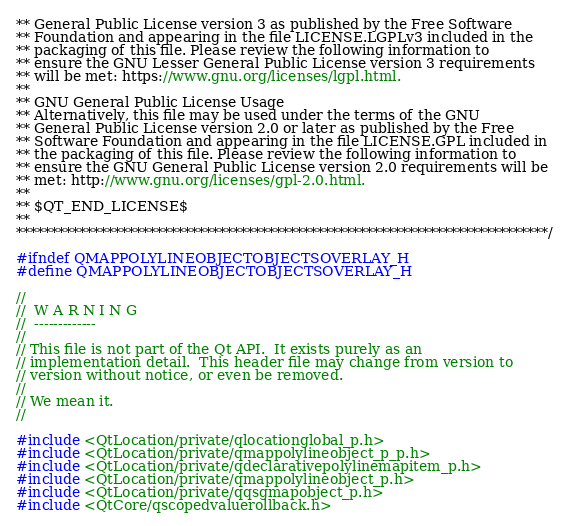<code> <loc_0><loc_0><loc_500><loc_500><_C_>** General Public License version 3 as published by the Free Software
** Foundation and appearing in the file LICENSE.LGPLv3 included in the
** packaging of this file. Please review the following information to
** ensure the GNU Lesser General Public License version 3 requirements
** will be met: https://www.gnu.org/licenses/lgpl.html.
**
** GNU General Public License Usage
** Alternatively, this file may be used under the terms of the GNU
** General Public License version 2.0 or later as published by the Free
** Software Foundation and appearing in the file LICENSE.GPL included in
** the packaging of this file. Please review the following information to
** ensure the GNU General Public License version 2.0 requirements will be
** met: http://www.gnu.org/licenses/gpl-2.0.html.
**
** $QT_END_LICENSE$
**
****************************************************************************/

#ifndef QMAPPOLYLINEOBJECTOBJECTSOVERLAY_H
#define QMAPPOLYLINEOBJECTOBJECTSOVERLAY_H

//
//  W A R N I N G
//  -------------
//
// This file is not part of the Qt API.  It exists purely as an
// implementation detail.  This header file may change from version to
// version without notice, or even be removed.
//
// We mean it.
//

#include <QtLocation/private/qlocationglobal_p.h>
#include <QtLocation/private/qmappolylineobject_p_p.h>
#include <QtLocation/private/qdeclarativepolylinemapitem_p.h>
#include <QtLocation/private/qmappolylineobject_p.h>
#include <QtLocation/private/qqsgmapobject_p.h>
#include <QtCore/qscopedvaluerollback.h></code> 